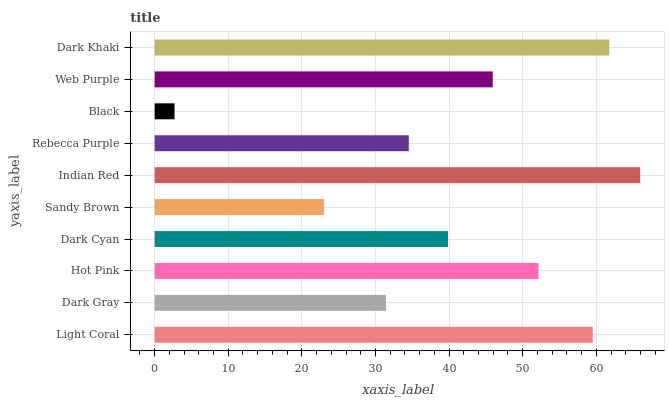Is Black the minimum?
Answer yes or no. Yes. Is Indian Red the maximum?
Answer yes or no. Yes. Is Dark Gray the minimum?
Answer yes or no. No. Is Dark Gray the maximum?
Answer yes or no. No. Is Light Coral greater than Dark Gray?
Answer yes or no. Yes. Is Dark Gray less than Light Coral?
Answer yes or no. Yes. Is Dark Gray greater than Light Coral?
Answer yes or no. No. Is Light Coral less than Dark Gray?
Answer yes or no. No. Is Web Purple the high median?
Answer yes or no. Yes. Is Dark Cyan the low median?
Answer yes or no. Yes. Is Light Coral the high median?
Answer yes or no. No. Is Web Purple the low median?
Answer yes or no. No. 